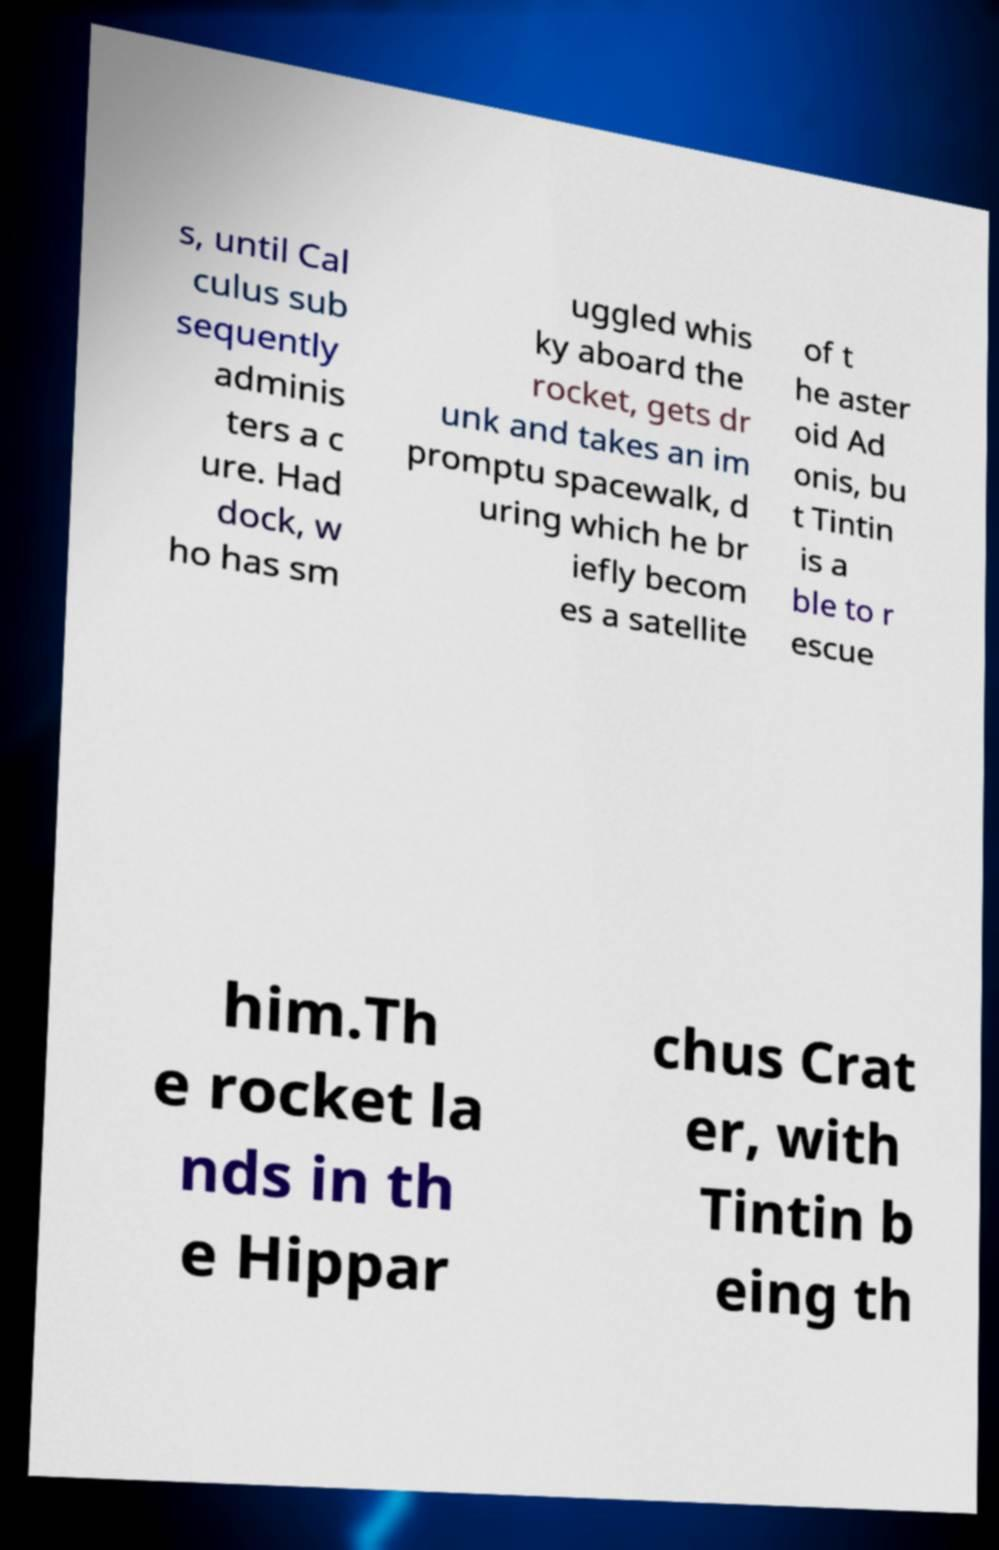Could you extract and type out the text from this image? s, until Cal culus sub sequently adminis ters a c ure. Had dock, w ho has sm uggled whis ky aboard the rocket, gets dr unk and takes an im promptu spacewalk, d uring which he br iefly becom es a satellite of t he aster oid Ad onis, bu t Tintin is a ble to r escue him.Th e rocket la nds in th e Hippar chus Crat er, with Tintin b eing th 